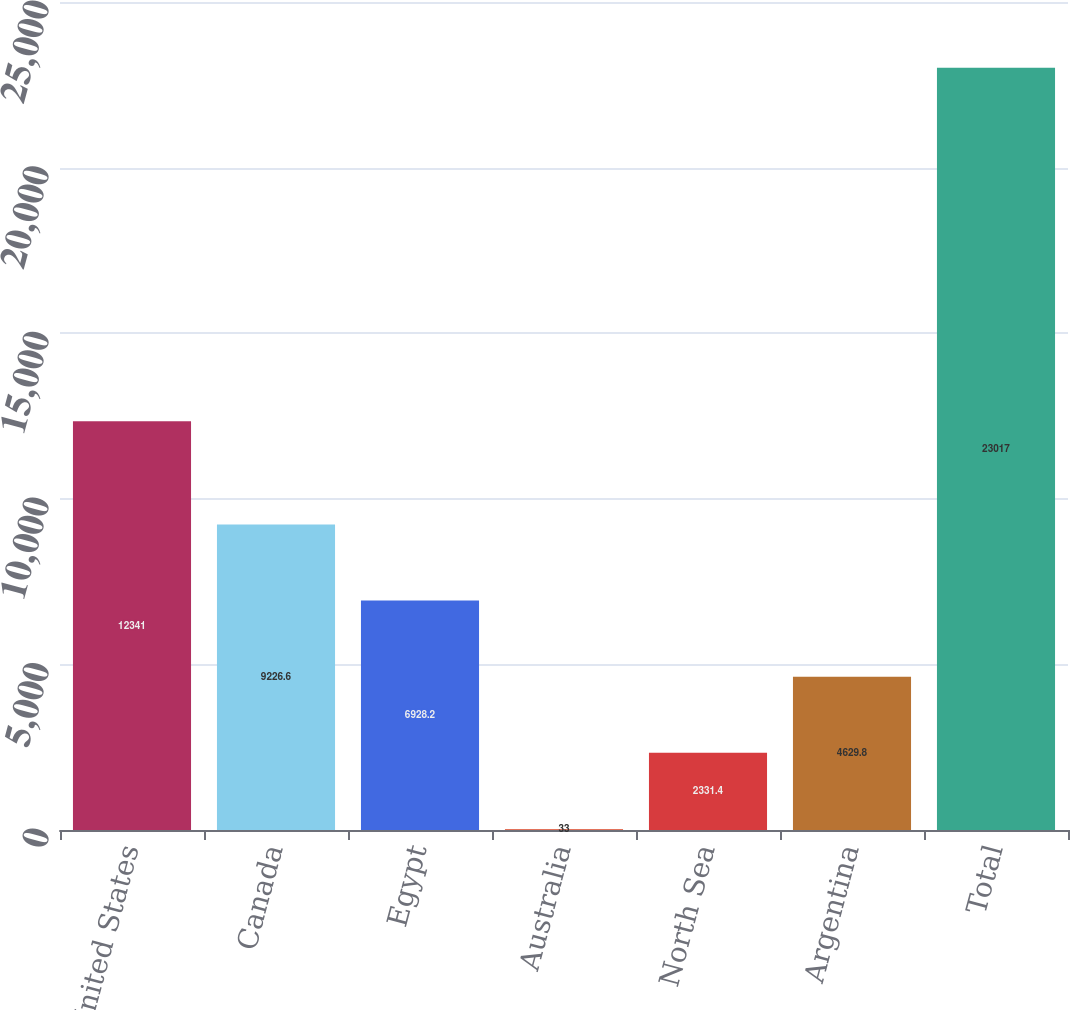<chart> <loc_0><loc_0><loc_500><loc_500><bar_chart><fcel>United States<fcel>Canada<fcel>Egypt<fcel>Australia<fcel>North Sea<fcel>Argentina<fcel>Total<nl><fcel>12341<fcel>9226.6<fcel>6928.2<fcel>33<fcel>2331.4<fcel>4629.8<fcel>23017<nl></chart> 